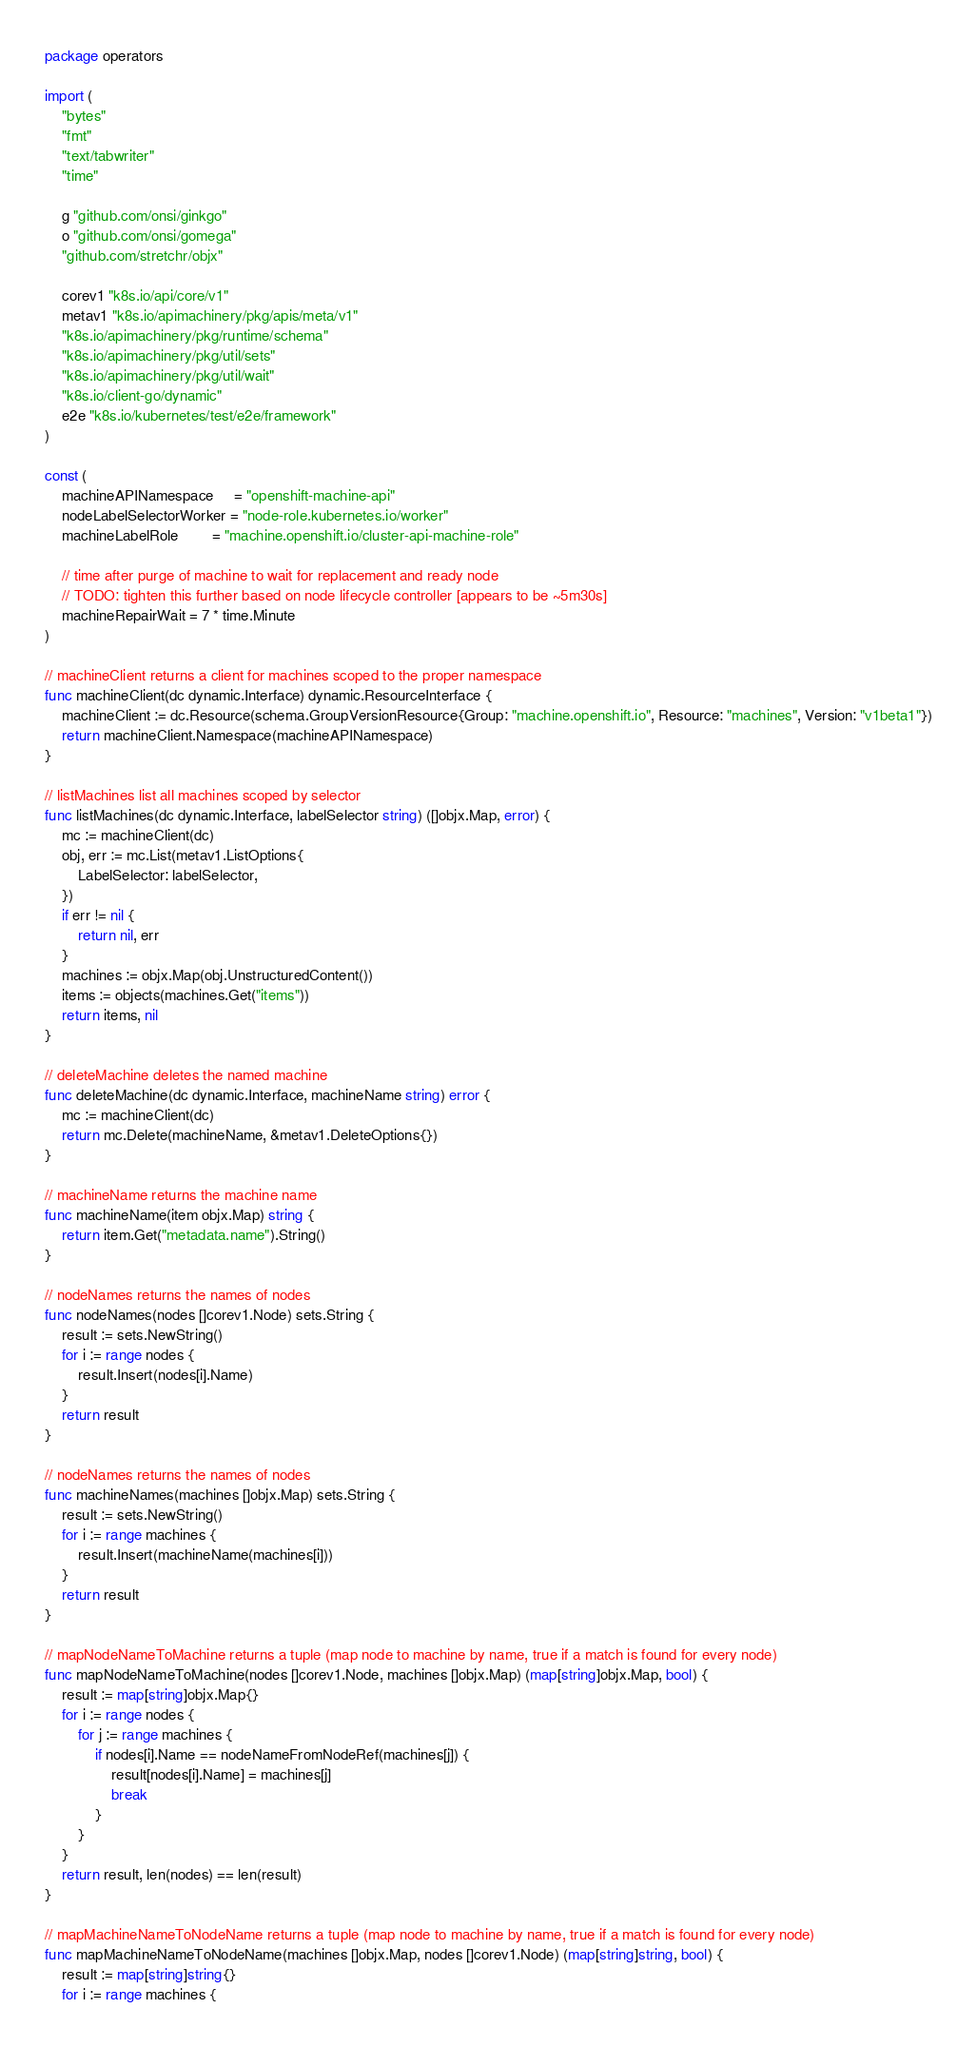Convert code to text. <code><loc_0><loc_0><loc_500><loc_500><_Go_>package operators

import (
	"bytes"
	"fmt"
	"text/tabwriter"
	"time"

	g "github.com/onsi/ginkgo"
	o "github.com/onsi/gomega"
	"github.com/stretchr/objx"

	corev1 "k8s.io/api/core/v1"
	metav1 "k8s.io/apimachinery/pkg/apis/meta/v1"
	"k8s.io/apimachinery/pkg/runtime/schema"
	"k8s.io/apimachinery/pkg/util/sets"
	"k8s.io/apimachinery/pkg/util/wait"
	"k8s.io/client-go/dynamic"
	e2e "k8s.io/kubernetes/test/e2e/framework"
)

const (
	machineAPINamespace     = "openshift-machine-api"
	nodeLabelSelectorWorker = "node-role.kubernetes.io/worker"
	machineLabelRole        = "machine.openshift.io/cluster-api-machine-role"

	// time after purge of machine to wait for replacement and ready node
	// TODO: tighten this further based on node lifecycle controller [appears to be ~5m30s]
	machineRepairWait = 7 * time.Minute
)

// machineClient returns a client for machines scoped to the proper namespace
func machineClient(dc dynamic.Interface) dynamic.ResourceInterface {
	machineClient := dc.Resource(schema.GroupVersionResource{Group: "machine.openshift.io", Resource: "machines", Version: "v1beta1"})
	return machineClient.Namespace(machineAPINamespace)
}

// listMachines list all machines scoped by selector
func listMachines(dc dynamic.Interface, labelSelector string) ([]objx.Map, error) {
	mc := machineClient(dc)
	obj, err := mc.List(metav1.ListOptions{
		LabelSelector: labelSelector,
	})
	if err != nil {
		return nil, err
	}
	machines := objx.Map(obj.UnstructuredContent())
	items := objects(machines.Get("items"))
	return items, nil
}

// deleteMachine deletes the named machine
func deleteMachine(dc dynamic.Interface, machineName string) error {
	mc := machineClient(dc)
	return mc.Delete(machineName, &metav1.DeleteOptions{})
}

// machineName returns the machine name
func machineName(item objx.Map) string {
	return item.Get("metadata.name").String()
}

// nodeNames returns the names of nodes
func nodeNames(nodes []corev1.Node) sets.String {
	result := sets.NewString()
	for i := range nodes {
		result.Insert(nodes[i].Name)
	}
	return result
}

// nodeNames returns the names of nodes
func machineNames(machines []objx.Map) sets.String {
	result := sets.NewString()
	for i := range machines {
		result.Insert(machineName(machines[i]))
	}
	return result
}

// mapNodeNameToMachine returns a tuple (map node to machine by name, true if a match is found for every node)
func mapNodeNameToMachine(nodes []corev1.Node, machines []objx.Map) (map[string]objx.Map, bool) {
	result := map[string]objx.Map{}
	for i := range nodes {
		for j := range machines {
			if nodes[i].Name == nodeNameFromNodeRef(machines[j]) {
				result[nodes[i].Name] = machines[j]
				break
			}
		}
	}
	return result, len(nodes) == len(result)
}

// mapMachineNameToNodeName returns a tuple (map node to machine by name, true if a match is found for every node)
func mapMachineNameToNodeName(machines []objx.Map, nodes []corev1.Node) (map[string]string, bool) {
	result := map[string]string{}
	for i := range machines {</code> 